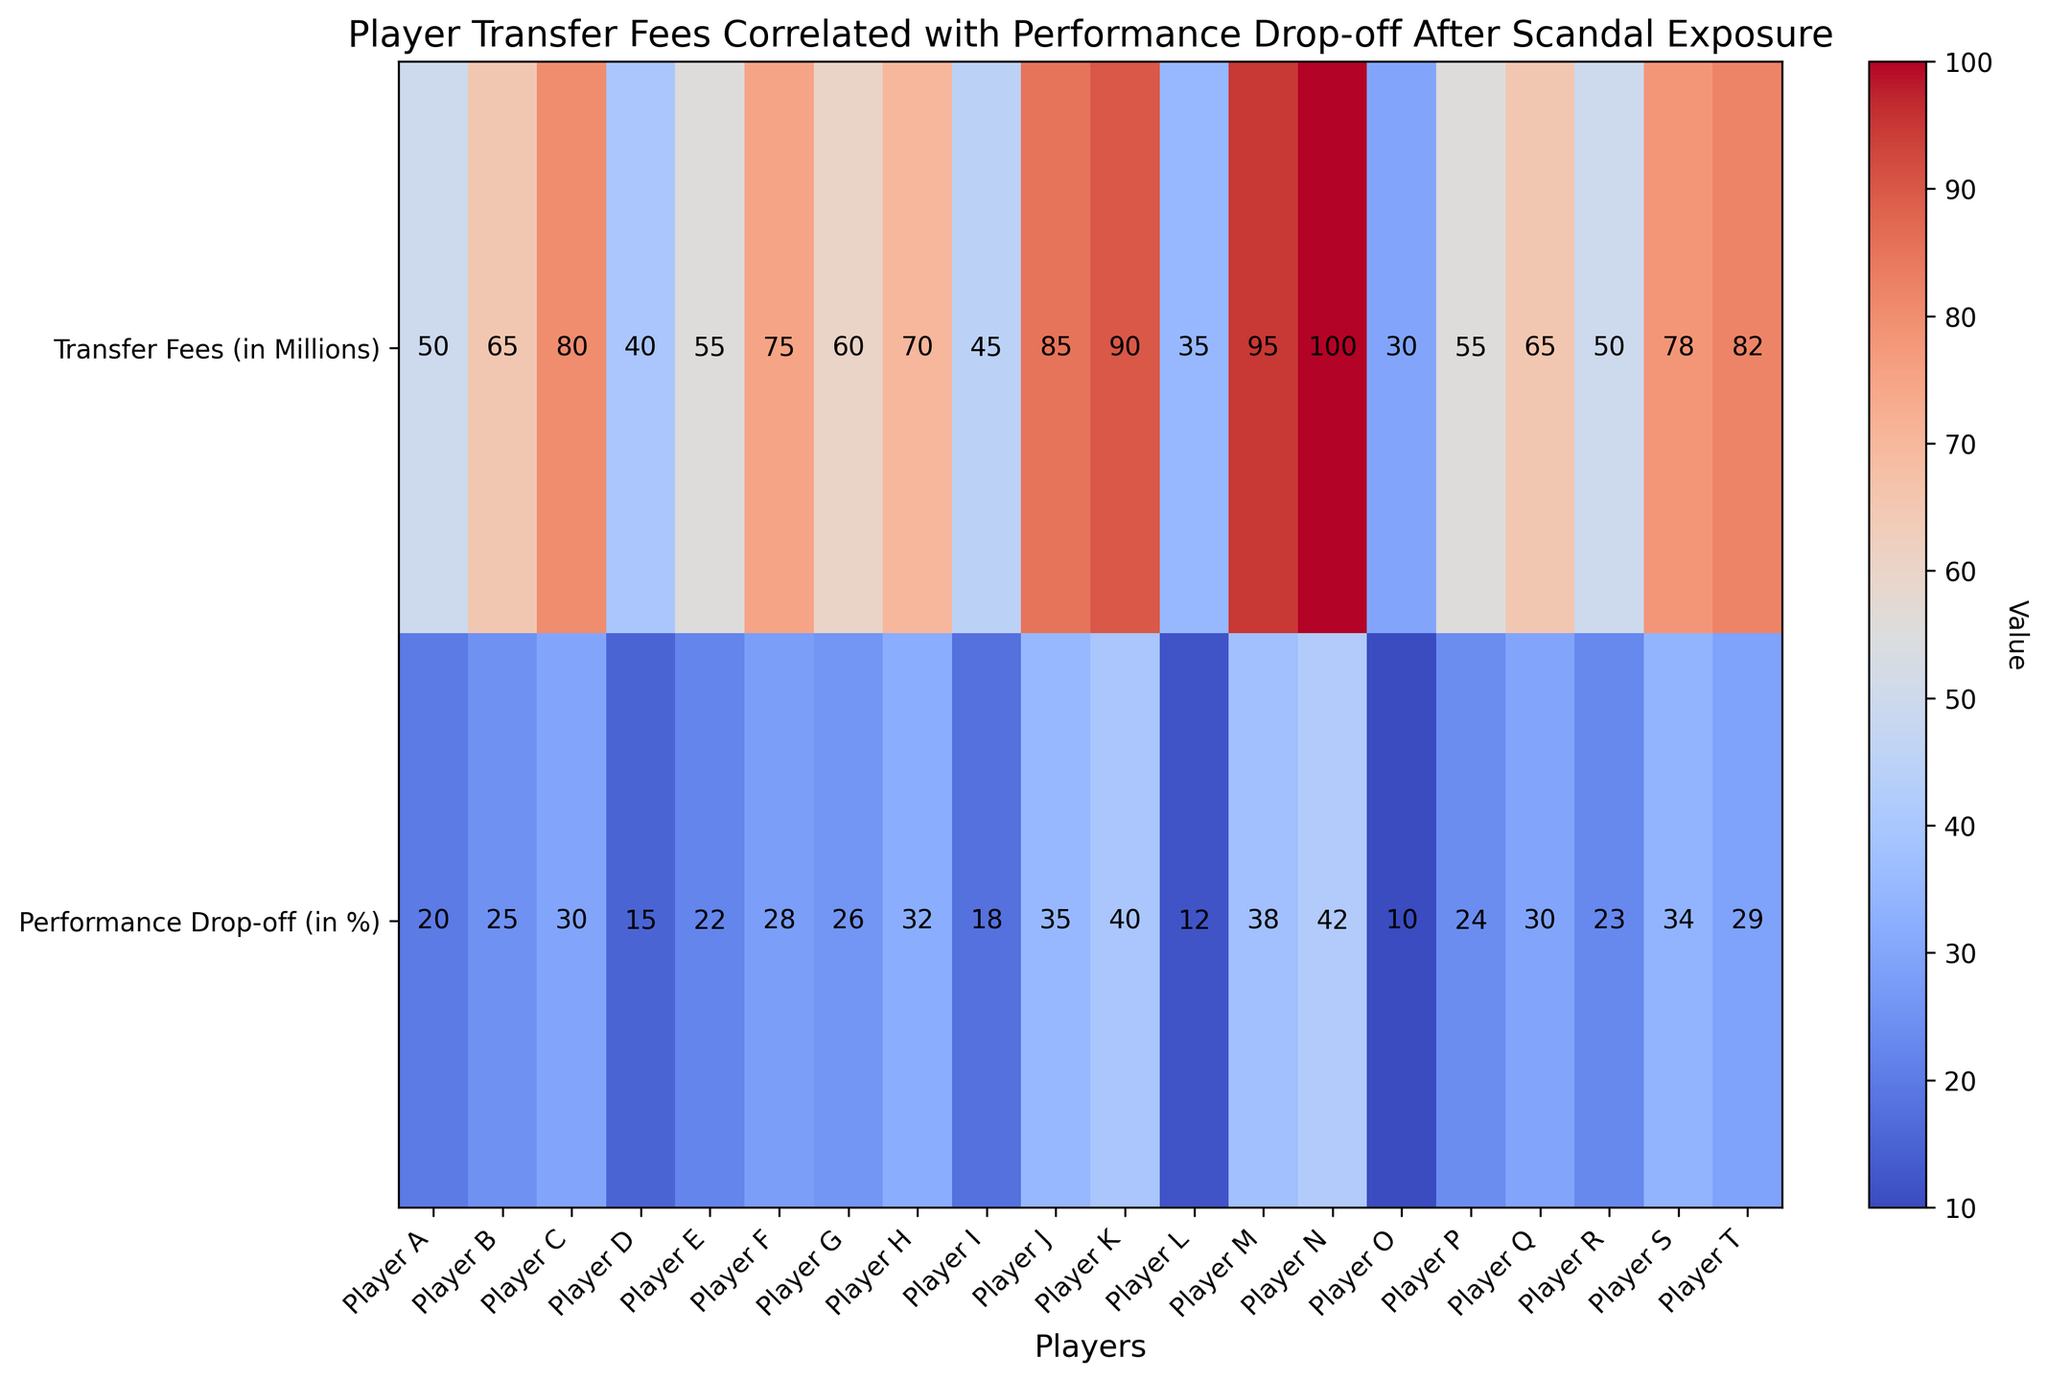Which player has the highest transfer fee? The player with the highest transfer fee is the one with the largest value in the "Transfer Fees (in Millions)" row. By examining the figure, Player N has the highest transfer fee of 100 million.
Answer: Player N Which players have a performance drop-off greater than 30%? Players with a performance drop-off greater than 30% will have values higher than 30 in the "Performance Drop-off (in %)" row. By checking the chart, Players H, J, K, M, N, and S have performance drop-offs greater than 30%.
Answer: Players H, J, K, M, N, S What is the average transfer fee of players whose performance drop-off is less than 20%? First, identify players with performance drop-off less than 20%. These are Player D, I, L, and O. Next, retrieve their transfer fees: 40, 45, 35, and 30 million. Sum these values (40 + 45 + 35 + 30 = 150) and divide by the number of players (4) to find the average.
Answer: 37.5 million Which player has the largest difference between transfer fee and performance drop-off? To find the largest difference, subtract the performance drop-off percentage from the transfer fee for each player and identify the maximum value. Player N, with a transfer fee of 100 and a drop-off of 42, has the largest difference of 58 (100 - 42).
Answer: Player N What is the total transfer fee of players with a performance drop-off between 20% and 30%? Identify players with performance drop-off between 20% and 30%: Players A, B, E, F, G, Q, and T. Sum their transfer fees: 50 + 65 + 55 + 75 + 60 + 65 + 82 = 452 million.
Answer: 452 million How does the color intensity vary between high and low transfer fees? In a heatmap, color intensity usually varies with the data value. Higher transfer fees are shown with more intense or darker colors compared to lower transfer fees, which appear lighter.
Answer: Higher fees are darker Which player has the smallest performance drop-off percentage? The smallest performance drop-off percentage is the lowest value in the "Performance Drop-off (in %)" row. Player O has the smallest drop-off of 10%.
Answer: Player O Compare the transfer fees of Players F and G and identify which one is greater. Examine the transfer fees for Players F and G. Player F has a transfer fee of 75 million, whereas Player G has a transfer fee of 60 million. Player F's fee is greater.
Answer: Player F What is the overall trend between transfer fees and performance drop-off visible in the heatmap? The heatmap displays a trend where players with higher transfer fees generally show higher performance drop-offs. This indicates a potential correlation where more expensive players are experiencing greater performance declines post-scandal.
Answer: Higher fees, higher drop-offs Is there any player with both a low transfer fee and a high performance drop-off? Check if any player has a transfer fee in the lower range (30-50 million) and a performance drop-off in the higher range (30%-42%). No player fits both conditions simultaneously.
Answer: No 